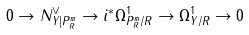<formula> <loc_0><loc_0><loc_500><loc_500>0 \to N ^ { \vee } _ { Y | { P } ^ { m } _ { R } } \to i ^ { * } \Omega ^ { 1 } _ { { P } ^ { m } _ { R } { / R } } \to \Omega ^ { 1 } _ { Y / R } \to 0</formula> 